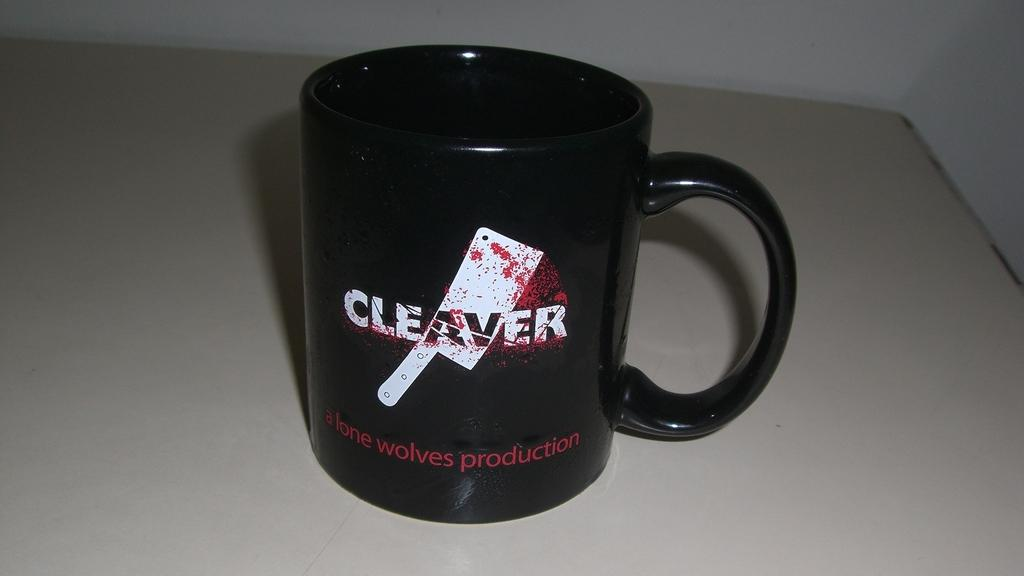<image>
Create a compact narrative representing the image presented. A black coffee mug sits on a counter and depicts a graphic from a movie that was done by alone wolves productions. 